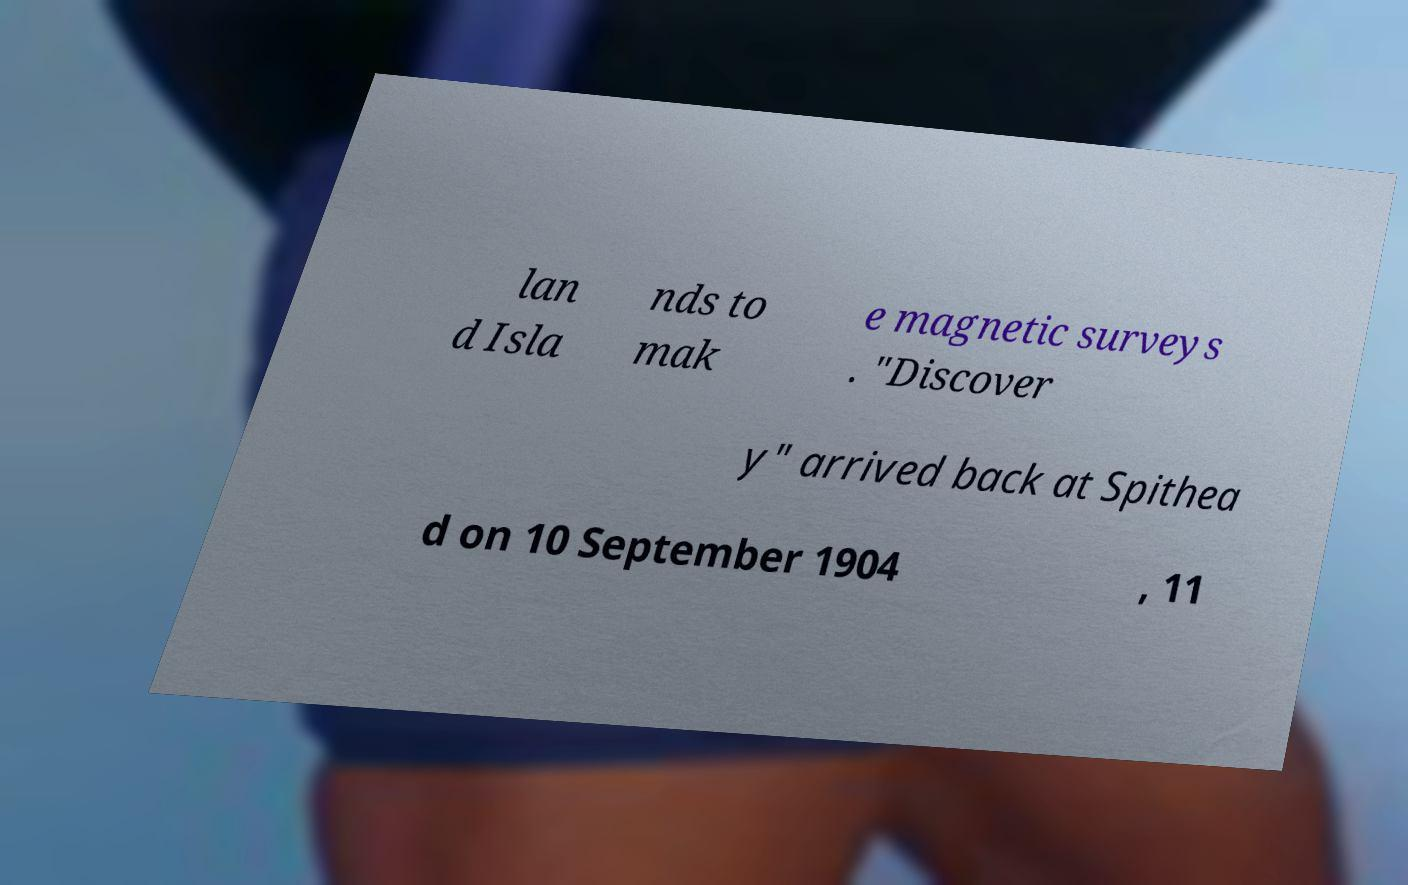Can you accurately transcribe the text from the provided image for me? lan d Isla nds to mak e magnetic surveys . "Discover y" arrived back at Spithea d on 10 September 1904 , 11 